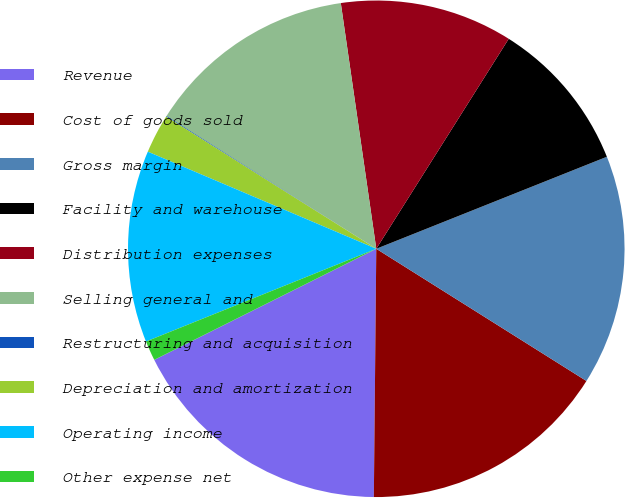<chart> <loc_0><loc_0><loc_500><loc_500><pie_chart><fcel>Revenue<fcel>Cost of goods sold<fcel>Gross margin<fcel>Facility and warehouse<fcel>Distribution expenses<fcel>Selling general and<fcel>Restructuring and acquisition<fcel>Depreciation and amortization<fcel>Operating income<fcel>Other expense net<nl><fcel>17.46%<fcel>16.22%<fcel>14.98%<fcel>10.0%<fcel>11.24%<fcel>13.73%<fcel>0.05%<fcel>2.54%<fcel>12.49%<fcel>1.29%<nl></chart> 